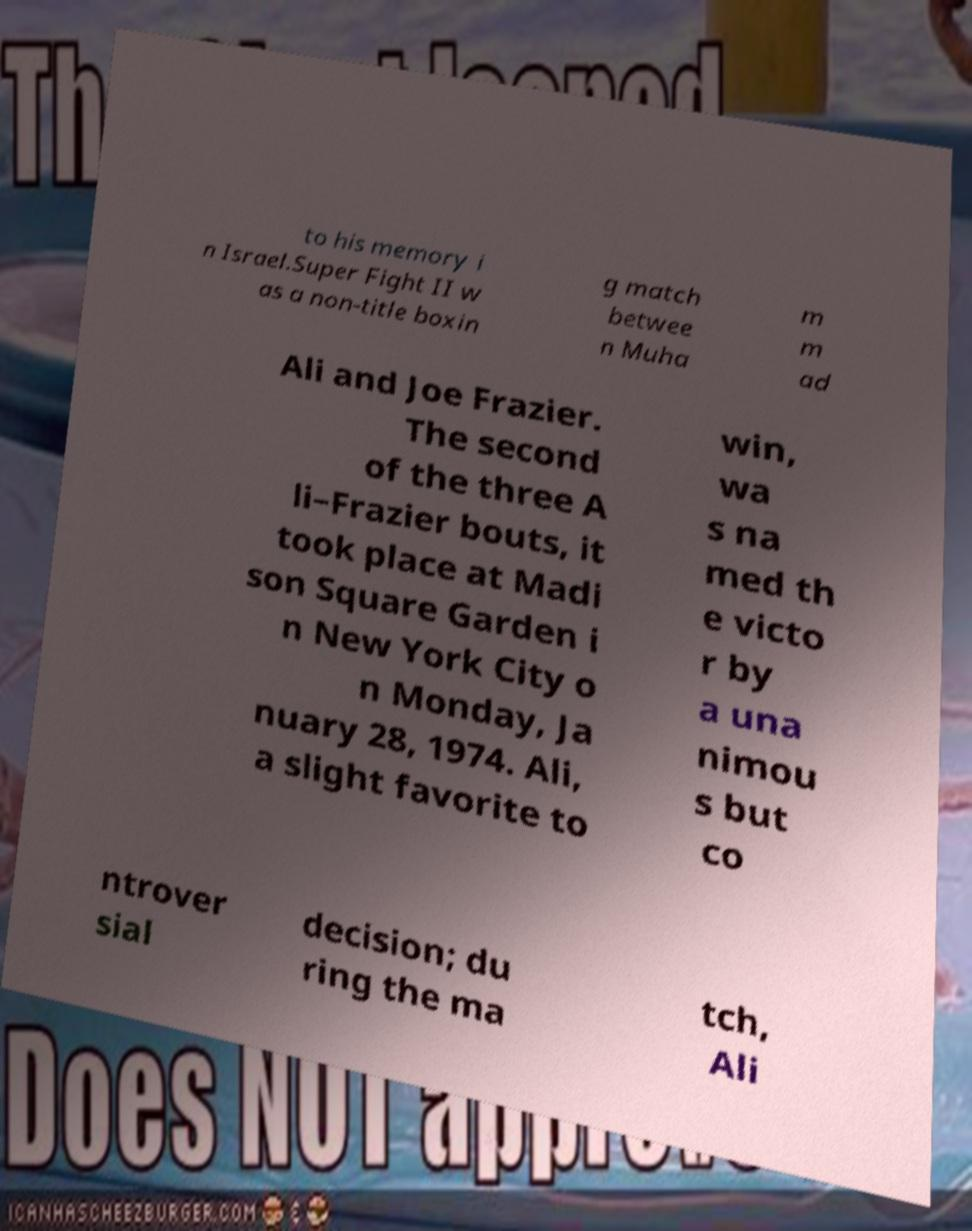Can you accurately transcribe the text from the provided image for me? to his memory i n Israel.Super Fight II w as a non-title boxin g match betwee n Muha m m ad Ali and Joe Frazier. The second of the three A li–Frazier bouts, it took place at Madi son Square Garden i n New York City o n Monday, Ja nuary 28, 1974. Ali, a slight favorite to win, wa s na med th e victo r by a una nimou s but co ntrover sial decision; du ring the ma tch, Ali 